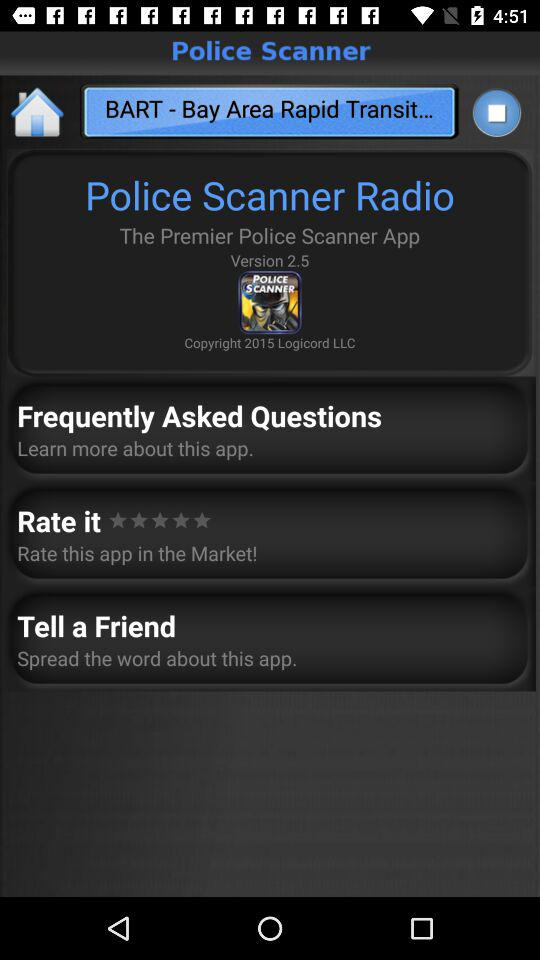What is the year of copyright of the application? The year of copyright is 2015. 